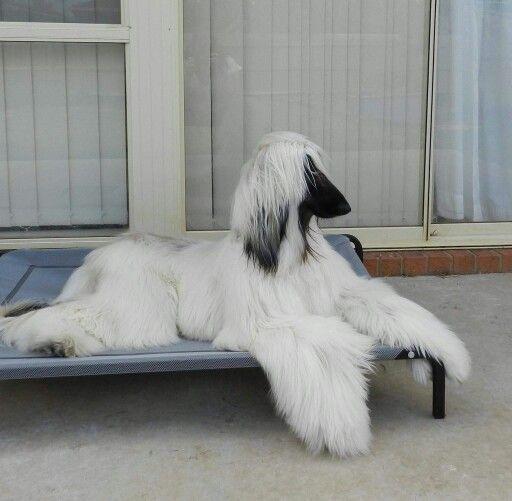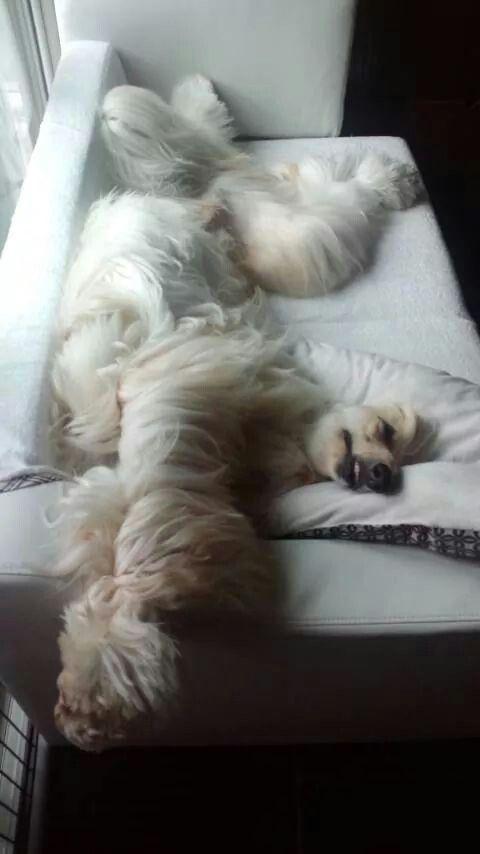The first image is the image on the left, the second image is the image on the right. Examine the images to the left and right. Is the description "An image shows a hound sleeping on a solid-white fabric-covered furniture item." accurate? Answer yes or no. Yes. 